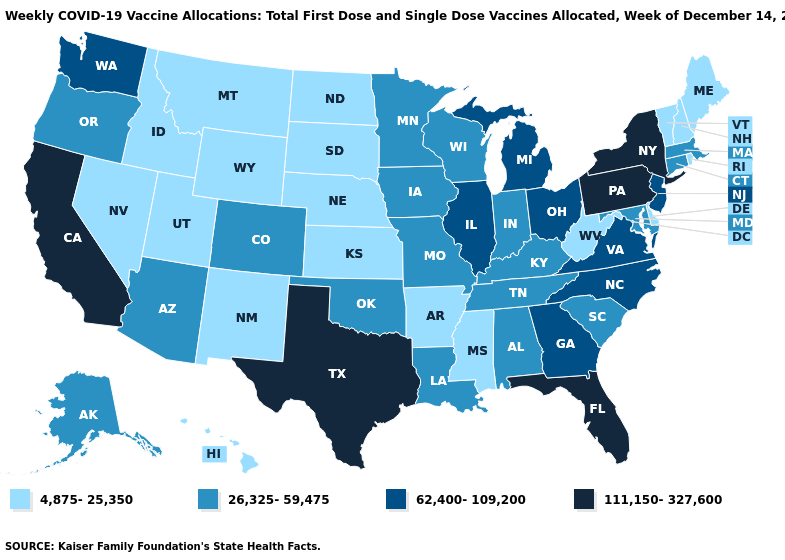What is the value of Iowa?
Be succinct. 26,325-59,475. Name the states that have a value in the range 111,150-327,600?
Quick response, please. California, Florida, New York, Pennsylvania, Texas. What is the value of Pennsylvania?
Quick response, please. 111,150-327,600. What is the value of New York?
Short answer required. 111,150-327,600. What is the value of Delaware?
Concise answer only. 4,875-25,350. What is the value of Kentucky?
Concise answer only. 26,325-59,475. What is the highest value in states that border Rhode Island?
Concise answer only. 26,325-59,475. What is the value of Iowa?
Quick response, please. 26,325-59,475. What is the value of Idaho?
Give a very brief answer. 4,875-25,350. Name the states that have a value in the range 62,400-109,200?
Concise answer only. Georgia, Illinois, Michigan, New Jersey, North Carolina, Ohio, Virginia, Washington. Which states have the highest value in the USA?
Give a very brief answer. California, Florida, New York, Pennsylvania, Texas. Among the states that border Ohio , which have the highest value?
Be succinct. Pennsylvania. What is the value of Massachusetts?
Concise answer only. 26,325-59,475. 